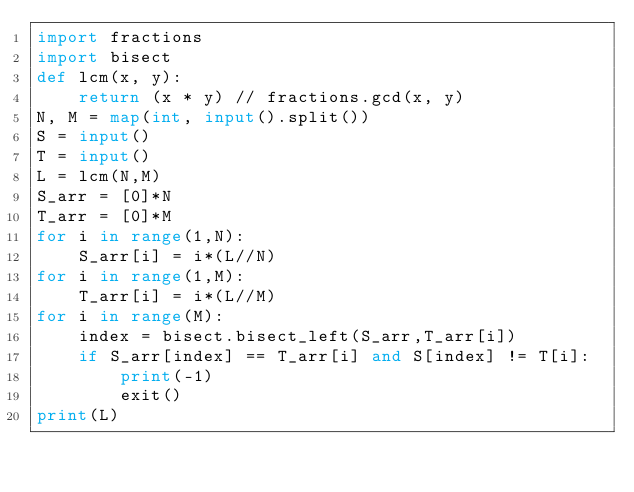<code> <loc_0><loc_0><loc_500><loc_500><_Python_>import fractions
import bisect
def lcm(x, y):
    return (x * y) // fractions.gcd(x, y)
N, M = map(int, input().split())
S = input()
T = input()
L = lcm(N,M)
S_arr = [0]*N
T_arr = [0]*M
for i in range(1,N):
    S_arr[i] = i*(L//N)
for i in range(1,M):
    T_arr[i] = i*(L//M)
for i in range(M):
    index = bisect.bisect_left(S_arr,T_arr[i])
    if S_arr[index] == T_arr[i] and S[index] != T[i]:
        print(-1)
        exit()
print(L)</code> 